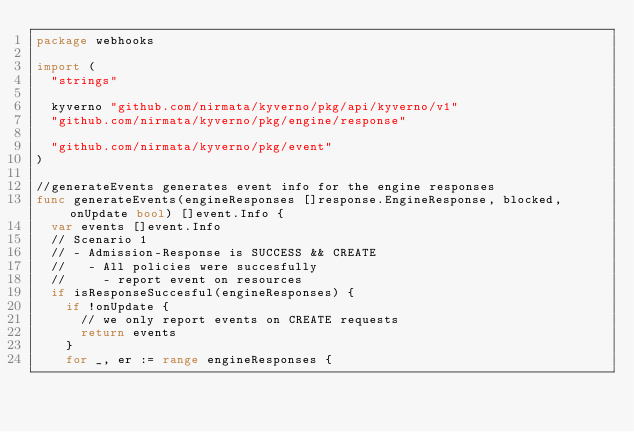Convert code to text. <code><loc_0><loc_0><loc_500><loc_500><_Go_>package webhooks

import (
	"strings"

	kyverno "github.com/nirmata/kyverno/pkg/api/kyverno/v1"
	"github.com/nirmata/kyverno/pkg/engine/response"

	"github.com/nirmata/kyverno/pkg/event"
)

//generateEvents generates event info for the engine responses
func generateEvents(engineResponses []response.EngineResponse, blocked, onUpdate bool) []event.Info {
	var events []event.Info
	// Scenario 1
	// - Admission-Response is SUCCESS && CREATE
	//   - All policies were succesfully
	//     - report event on resources
	if isResponseSuccesful(engineResponses) {
		if !onUpdate {
			// we only report events on CREATE requests
			return events
		}
		for _, er := range engineResponses {</code> 